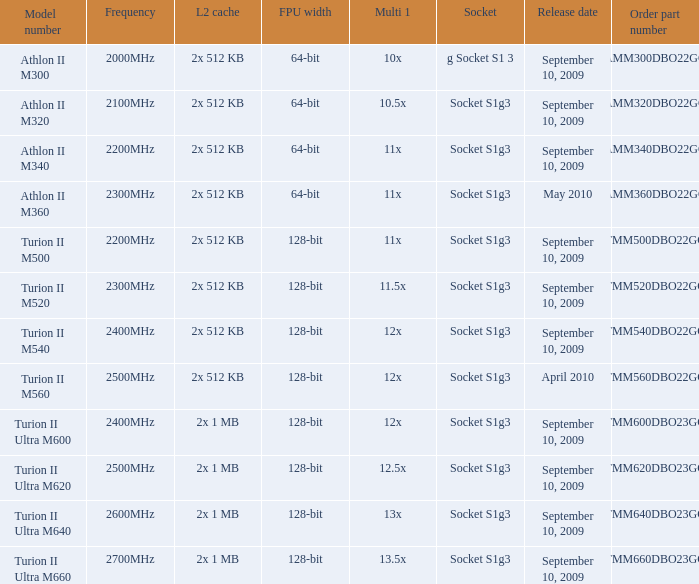What is the frequency of the tmm500dbo22gq order part number? 2200MHz. 